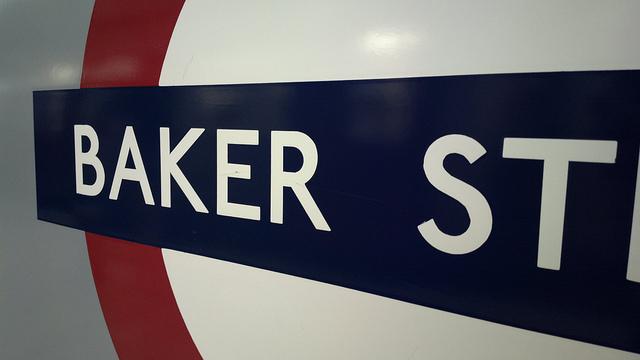What colors are in the sign?
Write a very short answer. Black and white. What street is this?
Answer briefly. Baker. What letter probably comes next on the right side?
Write a very short answer. R. 